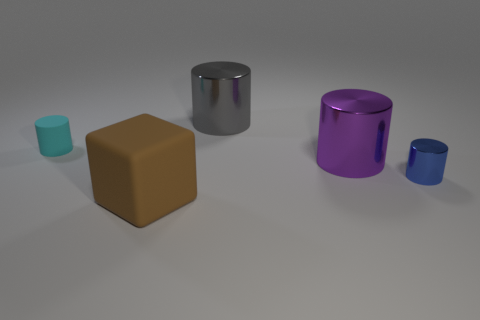Subtract all cyan cylinders. How many cylinders are left? 3 Add 3 large brown objects. How many objects exist? 8 Subtract all cylinders. How many objects are left? 1 Subtract 3 cylinders. How many cylinders are left? 1 Add 2 tiny blue cylinders. How many tiny blue cylinders are left? 3 Add 4 big purple metal cylinders. How many big purple metal cylinders exist? 5 Subtract all purple cylinders. How many cylinders are left? 3 Subtract 1 gray cylinders. How many objects are left? 4 Subtract all green cylinders. Subtract all blue balls. How many cylinders are left? 4 Subtract all purple cylinders. How many purple blocks are left? 0 